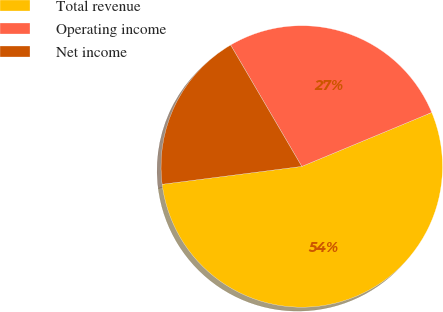Convert chart to OTSL. <chart><loc_0><loc_0><loc_500><loc_500><pie_chart><fcel>Total revenue<fcel>Operating income<fcel>Net income<nl><fcel>54.24%<fcel>27.17%<fcel>18.59%<nl></chart> 